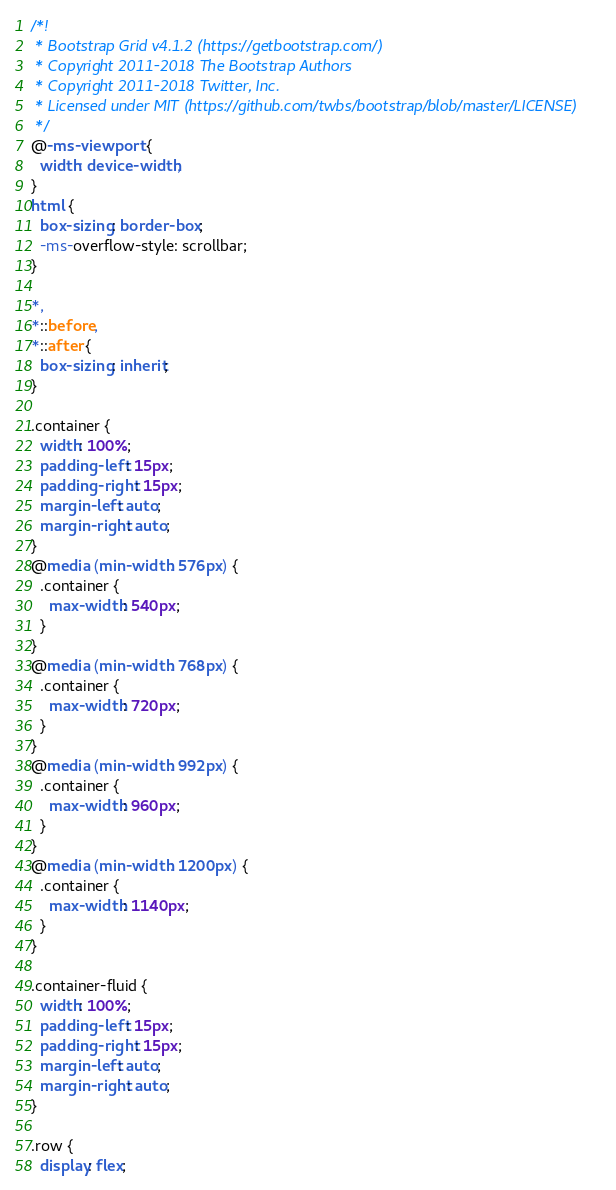<code> <loc_0><loc_0><loc_500><loc_500><_CSS_>/*!
 * Bootstrap Grid v4.1.2 (https://getbootstrap.com/)
 * Copyright 2011-2018 The Bootstrap Authors
 * Copyright 2011-2018 Twitter, Inc.
 * Licensed under MIT (https://github.com/twbs/bootstrap/blob/master/LICENSE)
 */
@-ms-viewport {
  width: device-width;
}
html {
  box-sizing: border-box;
  -ms-overflow-style: scrollbar;
}

*,
*::before,
*::after {
  box-sizing: inherit;
}

.container {
  width: 100%;
  padding-left: 15px;
  padding-right: 15px;
  margin-left: auto;
  margin-right: auto;
}
@media (min-width: 576px) {
  .container {
    max-width: 540px;
  }
}
@media (min-width: 768px) {
  .container {
    max-width: 720px;
  }
}
@media (min-width: 992px) {
  .container {
    max-width: 960px;
  }
}
@media (min-width: 1200px) {
  .container {
    max-width: 1140px;
  }
}

.container-fluid {
  width: 100%;
  padding-left: 15px;
  padding-right: 15px;
  margin-left: auto;
  margin-right: auto;
}

.row {
  display: flex;</code> 